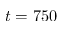Convert formula to latex. <formula><loc_0><loc_0><loc_500><loc_500>t = 7 5 0</formula> 